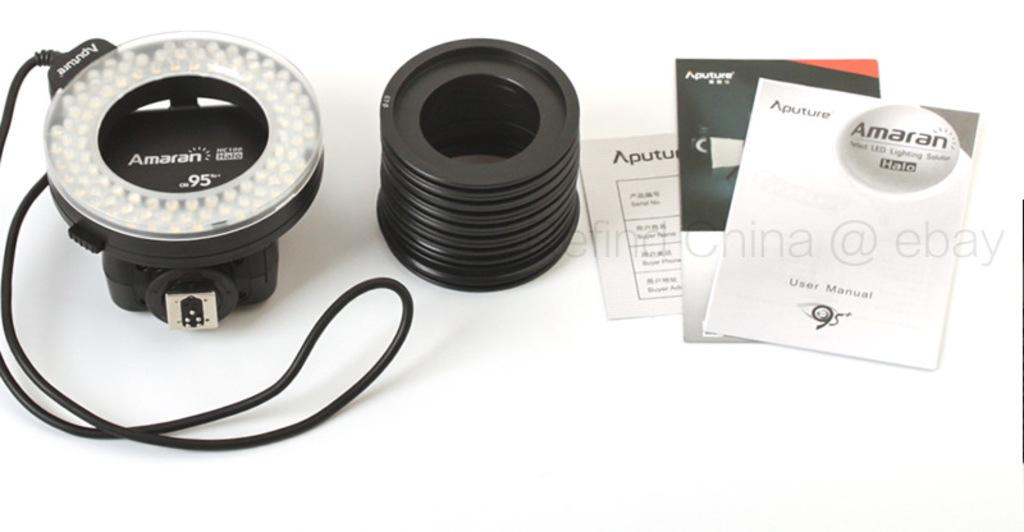What can be seen in the image? There are lines and papers on a table in the image. Can you describe the lines in the image? Unfortunately, the description of the lines is not provided in the facts. Where are the papers located in the image? The papers are on a table in the image. What type of kite is being played with on the table in the image? There is no kite present in the image; it only features lines and papers on a table. Can you tell me how many elbows are visible in the image? There is no reference to elbows in the image, as it only features lines and papers on a table. 